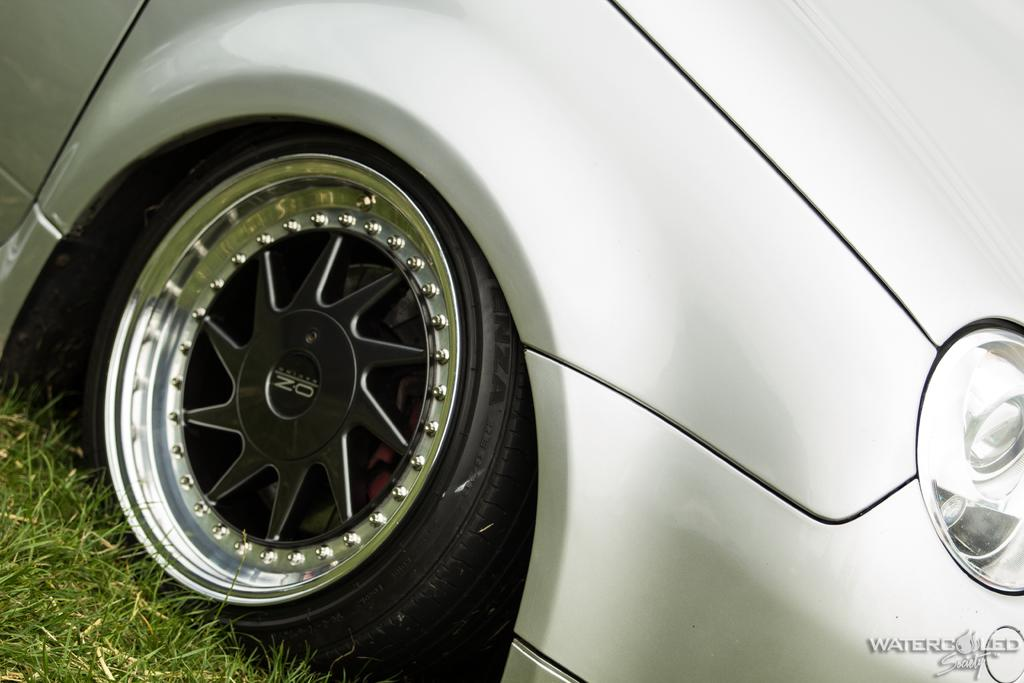What is the main subject of the picture? The main subject of the picture is a car. Can you describe any additional features or elements in the image? There is a watermark in the bottom right-hand side of the image. What type of force is being applied to the car in the image? There is no indication of any force being applied to the car in the image; it is stationary. Can you tell me how much water is visible in the image? There is no water present in the image. 